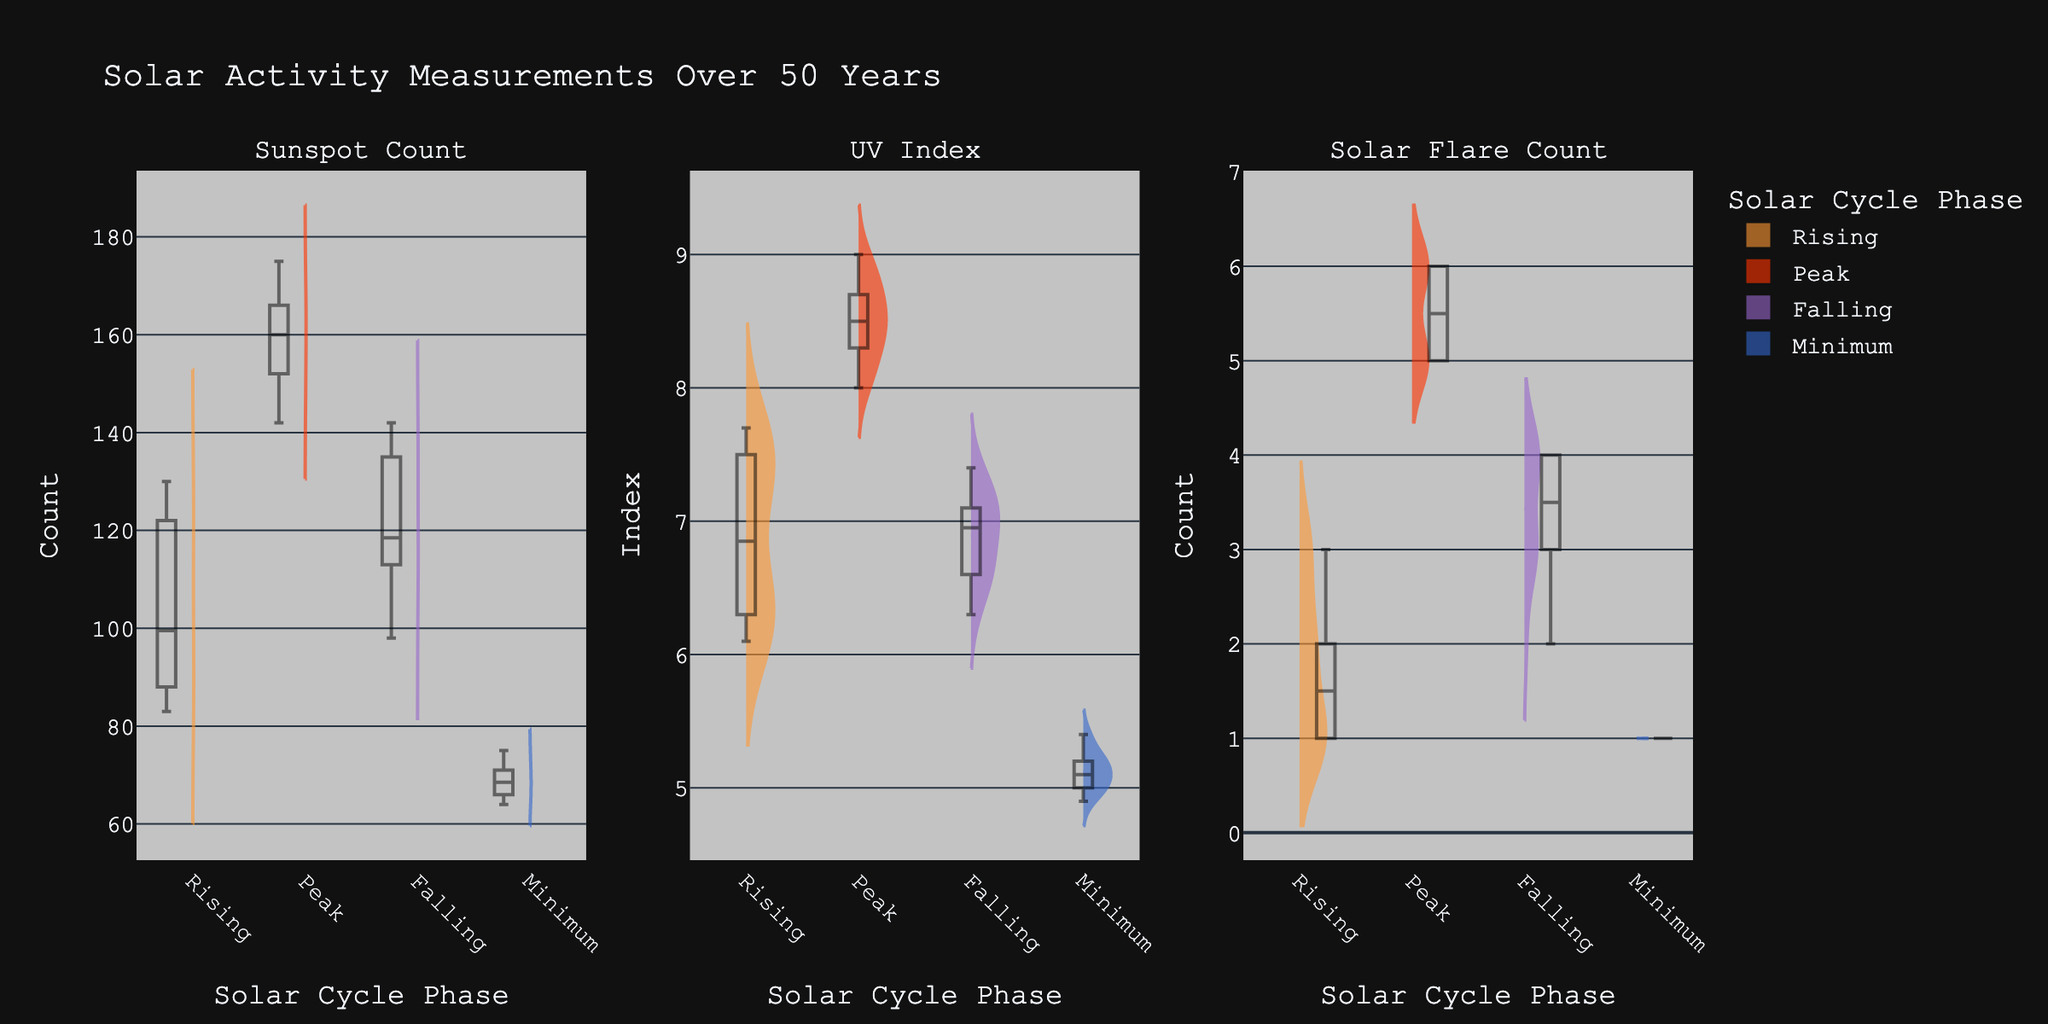What's the title of the figure? The title of the figure is usually displayed prominently at the top of the chart. In this case, the title is clearly stated at the top of the subplot layout.
Answer: Solar Activity Measurements Over 50 Years What are the three types of measurements shown in the figure? Looking at the labels of the three columns of subplots, they are clearly indicated. The sections are split by 'Sunspot Count', 'UV Index', and 'Solar Flare Count'.
Answer: Sunspot Count, UV Index, Solar Flare Count Which solar cycle phase shows the highest median sunspot count? The box plot within the violin plot for 'Sunspot Count' indicates the median value by a line. Observing the violin plot with the median line, the 'Peak' phase shows the highest median.
Answer: Peak What is the range of UV Index values during the Minimum phase? The range of values in a box plot can be inferred from the box itself for the interquartile range and the whiskers for the minimum and maximum values. For the 'Minimum' phase in the UV Index subplot, it spans from approximately 4.9 to 5.4.
Answer: 4.9 to 5.4 During which phase does Solar Flare Count have the most variability? Variability can be assessed by the spread of the data in the violin plot and the length of the whiskers in the box plot. The ‘Peak’ phase shows a wide spread, indicating high variability.
Answer: Peak Which solar cycle phase shows the smallest interquartile range for UV Index? The interquartile range (IQR) is the range between the first and third quartile, represented by the length of the box. In the UV Index subplot, the 'Minimum' phase has the smallest IQR, indicating less variability.
Answer: Minimum Between the Falling and Rising phases, which has a higher average Solar Flare Count? Comparing the central tendency for 'Solar Flare Count' within the violin box plot, the mean line (included in the Plotly Violin Plot) for 'Rising' is slightly higher than 'Falling'.
Answer: Rising What is the maximum sunspot count observed during the Rising phase? The upper whisker in the box plot within the 'Sunspot Count' subplot marks the maximum value. For the 'Rising' phase, this value can be observed to be around 130.
Answer: 130 How does the median UV Index compare between the Peak and Falling phases? Observing the median lines in the box plots for the 'UV Index', the Peak phase has a higher median value compared to the Falling phase.
Answer: Peak is higher Which phase shows the least solar activity overall across all three measurements? Looking at all three subplots and considering lower medians and spans, the 'Minimum' phase consistently shows lower values in Sunspot Count, UV Index, and Solar Flare Count.
Answer: Minimum 